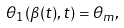<formula> <loc_0><loc_0><loc_500><loc_500>\theta _ { 1 } ( \beta ( t ) , t ) = \theta _ { m } ,</formula> 